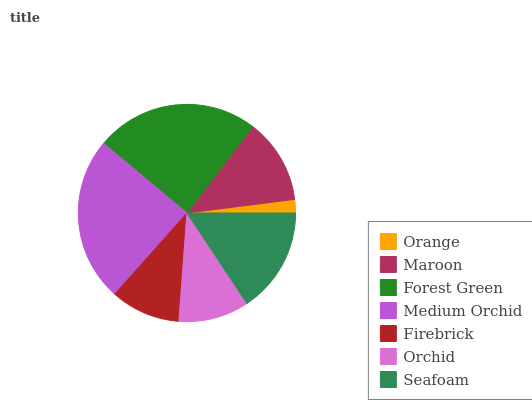Is Orange the minimum?
Answer yes or no. Yes. Is Medium Orchid the maximum?
Answer yes or no. Yes. Is Maroon the minimum?
Answer yes or no. No. Is Maroon the maximum?
Answer yes or no. No. Is Maroon greater than Orange?
Answer yes or no. Yes. Is Orange less than Maroon?
Answer yes or no. Yes. Is Orange greater than Maroon?
Answer yes or no. No. Is Maroon less than Orange?
Answer yes or no. No. Is Maroon the high median?
Answer yes or no. Yes. Is Maroon the low median?
Answer yes or no. Yes. Is Seafoam the high median?
Answer yes or no. No. Is Orchid the low median?
Answer yes or no. No. 